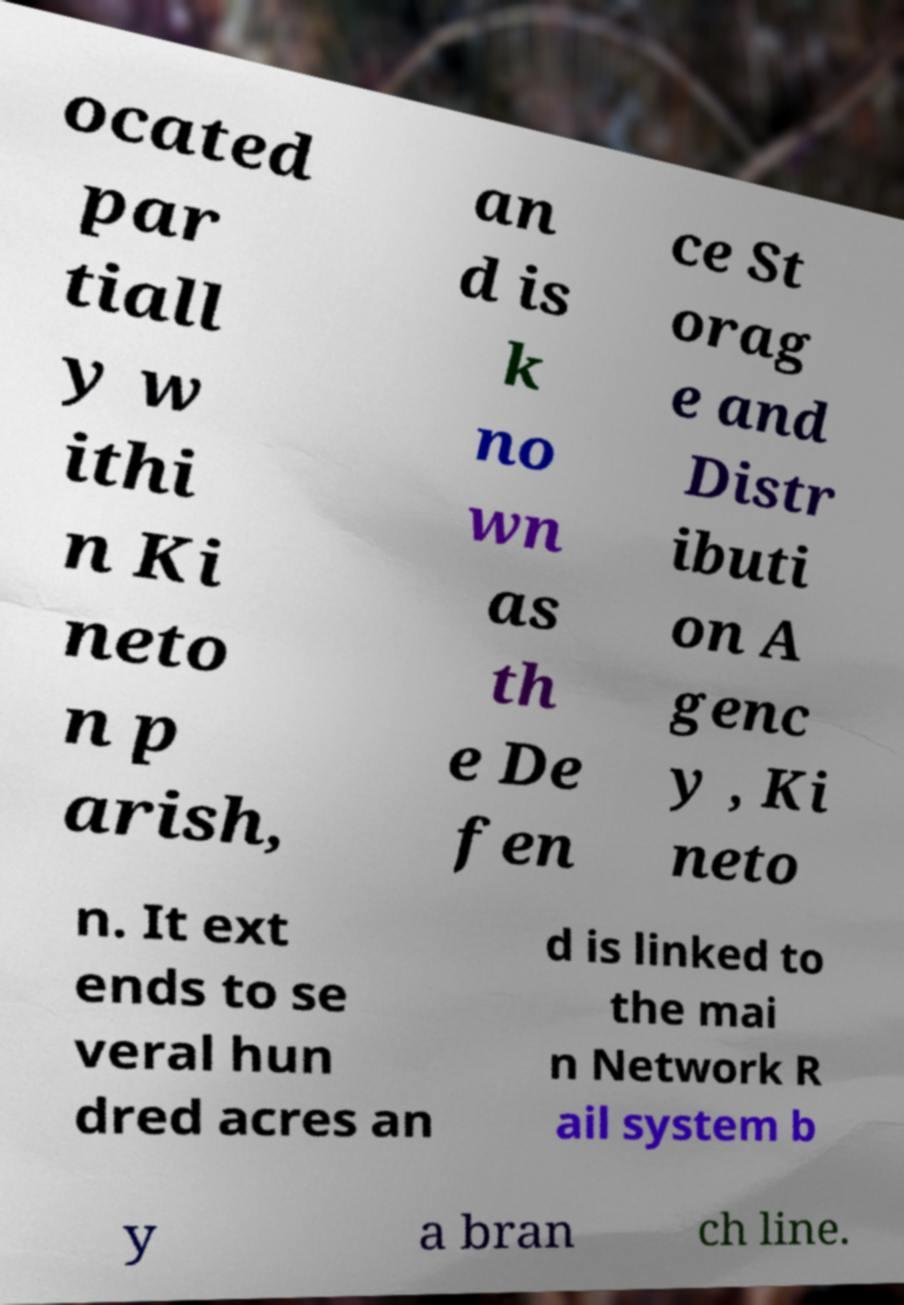I need the written content from this picture converted into text. Can you do that? ocated par tiall y w ithi n Ki neto n p arish, an d is k no wn as th e De fen ce St orag e and Distr ibuti on A genc y , Ki neto n. It ext ends to se veral hun dred acres an d is linked to the mai n Network R ail system b y a bran ch line. 